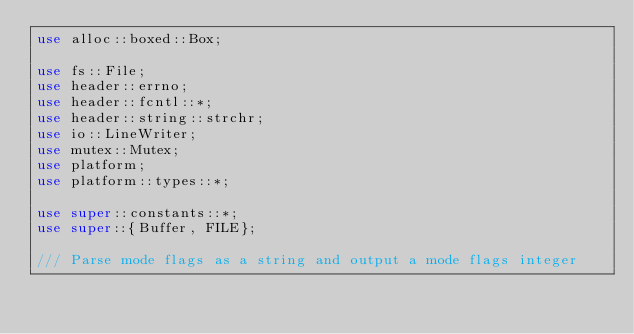<code> <loc_0><loc_0><loc_500><loc_500><_Rust_>use alloc::boxed::Box;

use fs::File;
use header::errno;
use header::fcntl::*;
use header::string::strchr;
use io::LineWriter;
use mutex::Mutex;
use platform;
use platform::types::*;

use super::constants::*;
use super::{Buffer, FILE};

/// Parse mode flags as a string and output a mode flags integer</code> 